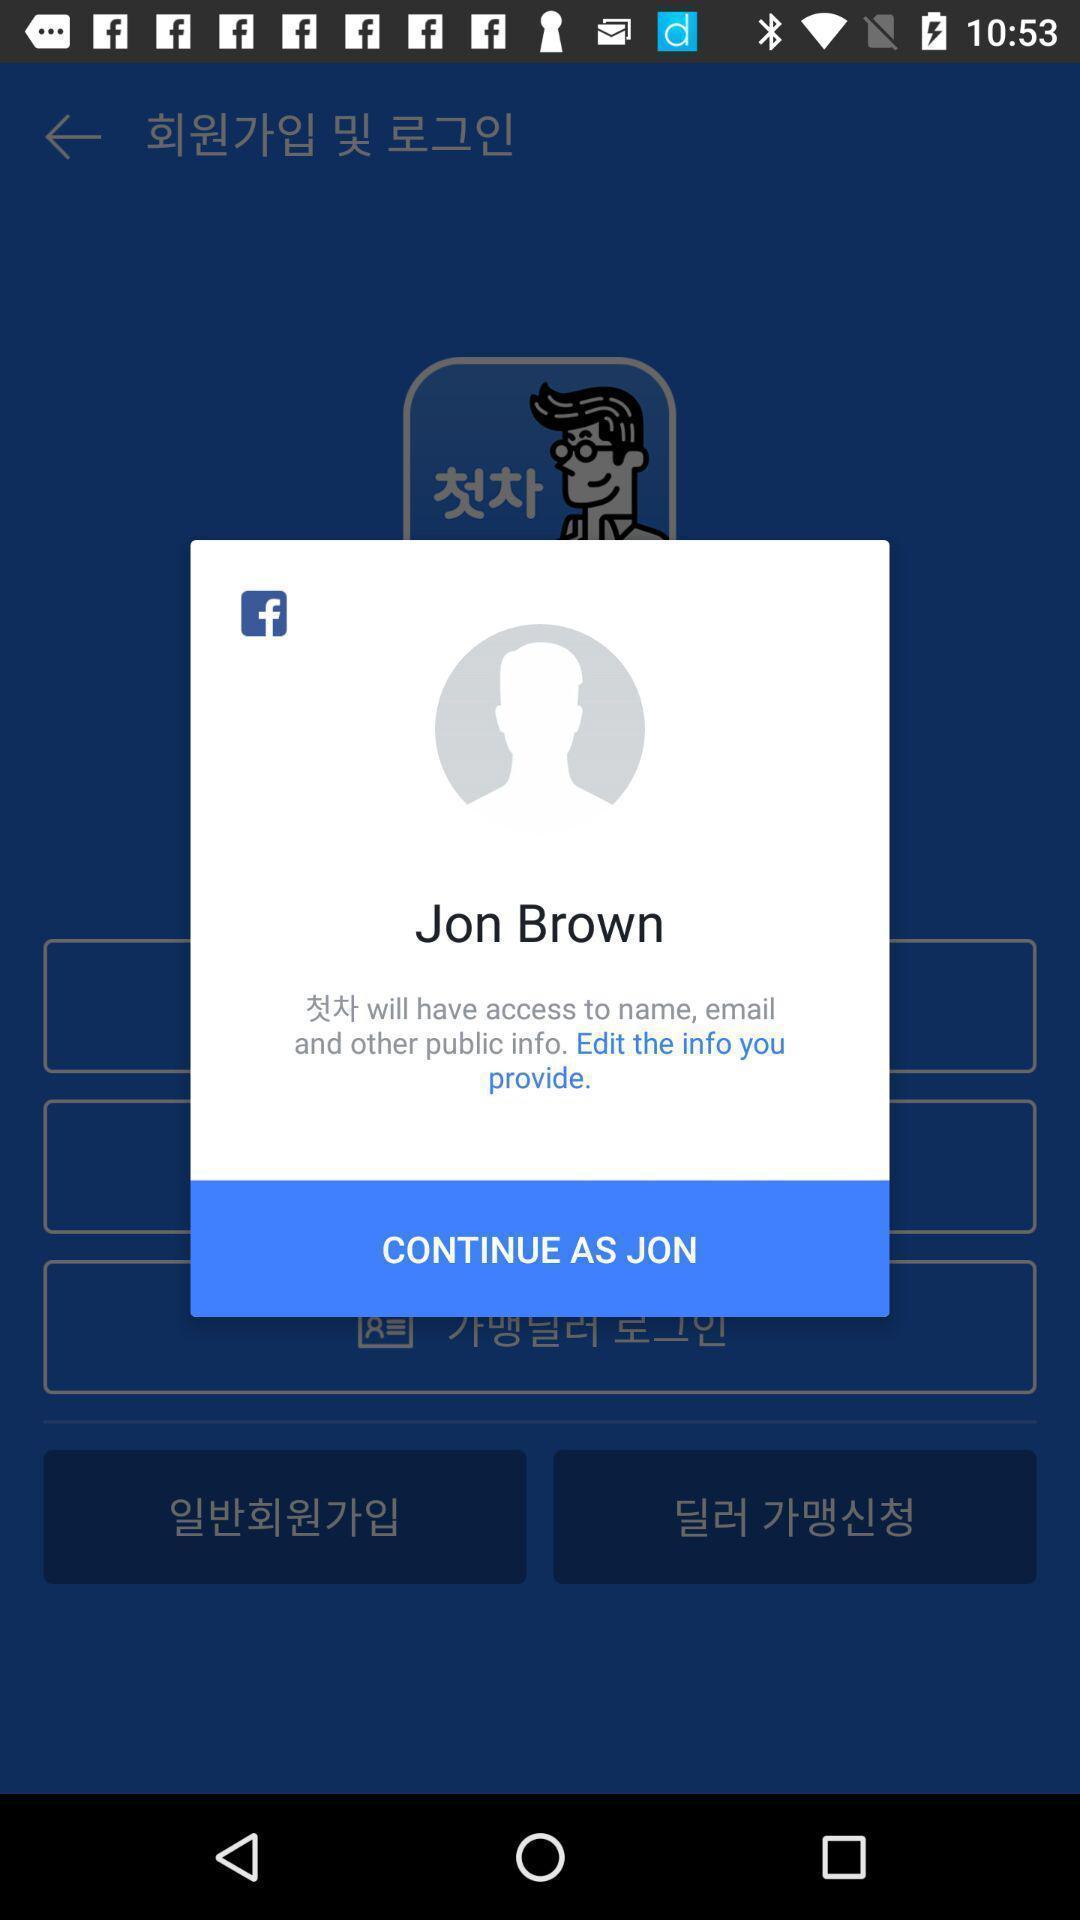What details can you identify in this image? Popup showing continue option. 